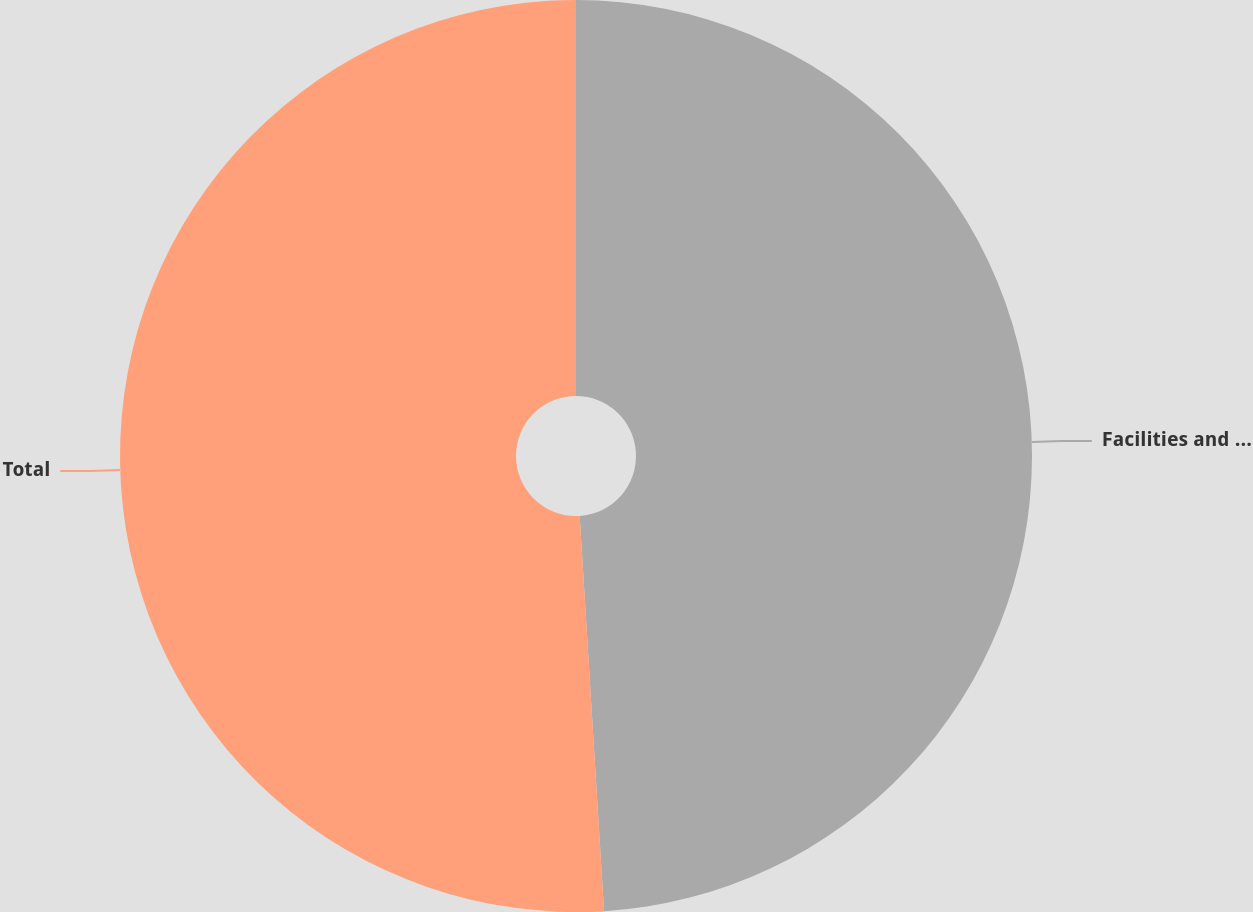Convert chart. <chart><loc_0><loc_0><loc_500><loc_500><pie_chart><fcel>Facilities and equipment<fcel>Total<nl><fcel>49.02%<fcel>50.98%<nl></chart> 